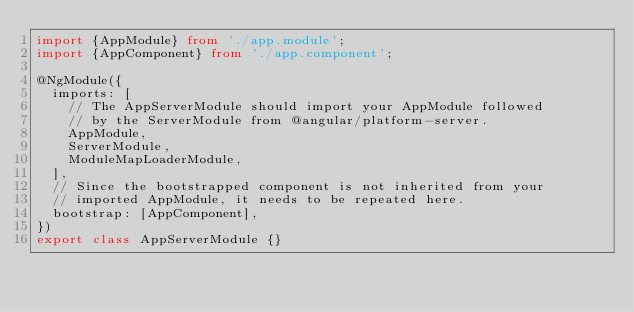<code> <loc_0><loc_0><loc_500><loc_500><_TypeScript_>import {AppModule} from './app.module';
import {AppComponent} from './app.component';

@NgModule({
  imports: [
    // The AppServerModule should import your AppModule followed
    // by the ServerModule from @angular/platform-server.
    AppModule,
    ServerModule,
    ModuleMapLoaderModule,
  ],
  // Since the bootstrapped component is not inherited from your
  // imported AppModule, it needs to be repeated here.
  bootstrap: [AppComponent],
})
export class AppServerModule {}
</code> 